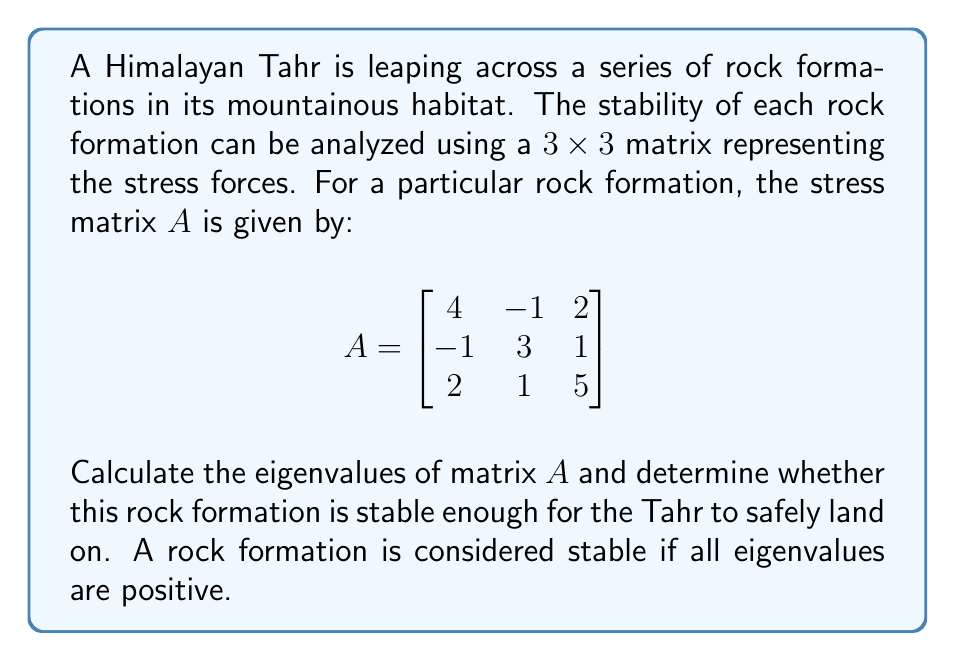Could you help me with this problem? To determine the stability of the rock formation, we need to find the eigenvalues of matrix $A$. Let's follow these steps:

1) The characteristic equation for matrix $A$ is given by:
   $\det(A - \lambda I) = 0$

2) Expanding this, we get:
   $$\begin{vmatrix}
   4-\lambda & -1 & 2 \\
   -1 & 3-\lambda & 1 \\
   2 & 1 & 5-\lambda
   \end{vmatrix} = 0$$

3) Calculating the determinant:
   $(4-\lambda)[(3-\lambda)(5-\lambda) - 1] - (-1)[(-1)(5-\lambda) - 2(1)] + 2[(-1)(1) - (3-\lambda)(2)] = 0$

4) Simplifying:
   $(4-\lambda)(15-8\lambda+\lambda^2-1) + (5-\lambda+4) + 2(-1-6+2\lambda) = 0$
   
   $(4-\lambda)(14-8\lambda+\lambda^2) + 9 + 2(-7+2\lambda) = 0$
   
   $56-32\lambda+4\lambda^2-14\lambda+8\lambda^2-\lambda^3 + 9 - 14 + 4\lambda = 0$

5) Collecting terms:
   $-\lambda^3 + 12\lambda^2 - 42\lambda + 51 = 0$

6) This cubic equation can be solved using various methods. Using a computer algebra system or numerical methods, we find the roots are:

   $\lambda_1 \approx 7.84$
   $\lambda_2 \approx 2.69$
   $\lambda_3 \approx 1.47$

7) Since all eigenvalues are positive, the rock formation is considered stable.
Answer: The eigenvalues are approximately 7.84, 2.69, and 1.47. As all eigenvalues are positive, the rock formation is stable enough for the Himalayan Tahr to safely land on. 